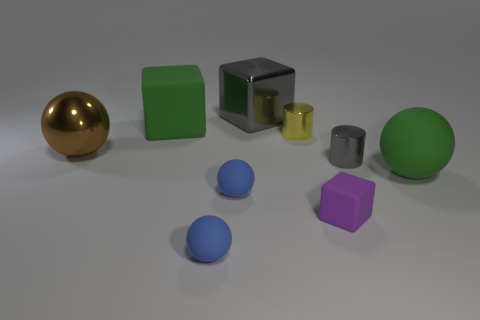There is a cylinder that is to the right of the yellow metal object; does it have the same color as the shiny block?
Provide a short and direct response. Yes. How many cylinders are the same color as the shiny block?
Ensure brevity in your answer.  1. What is the material of the large cube that is the same color as the large matte sphere?
Offer a very short reply. Rubber. What material is the brown object that is the same size as the gray block?
Your answer should be very brief. Metal. Do the big rubber object to the right of the small purple matte cube and the matte block that is behind the gray cylinder have the same color?
Make the answer very short. Yes. There is a tiny metal thing that is on the right side of the purple matte cube; is there a large green object that is in front of it?
Make the answer very short. Yes. There is a gray metallic object behind the large green rubber block; does it have the same shape as the large green matte thing on the left side of the green matte ball?
Offer a very short reply. Yes. Is the green object left of the big gray metal cube made of the same material as the gray object that is behind the small yellow shiny cylinder?
Make the answer very short. No. What material is the large ball to the left of the big green object in front of the large matte block made of?
Offer a terse response. Metal. What shape is the metal object that is behind the big green object that is on the left side of the large object that is right of the big shiny block?
Offer a very short reply. Cube. 